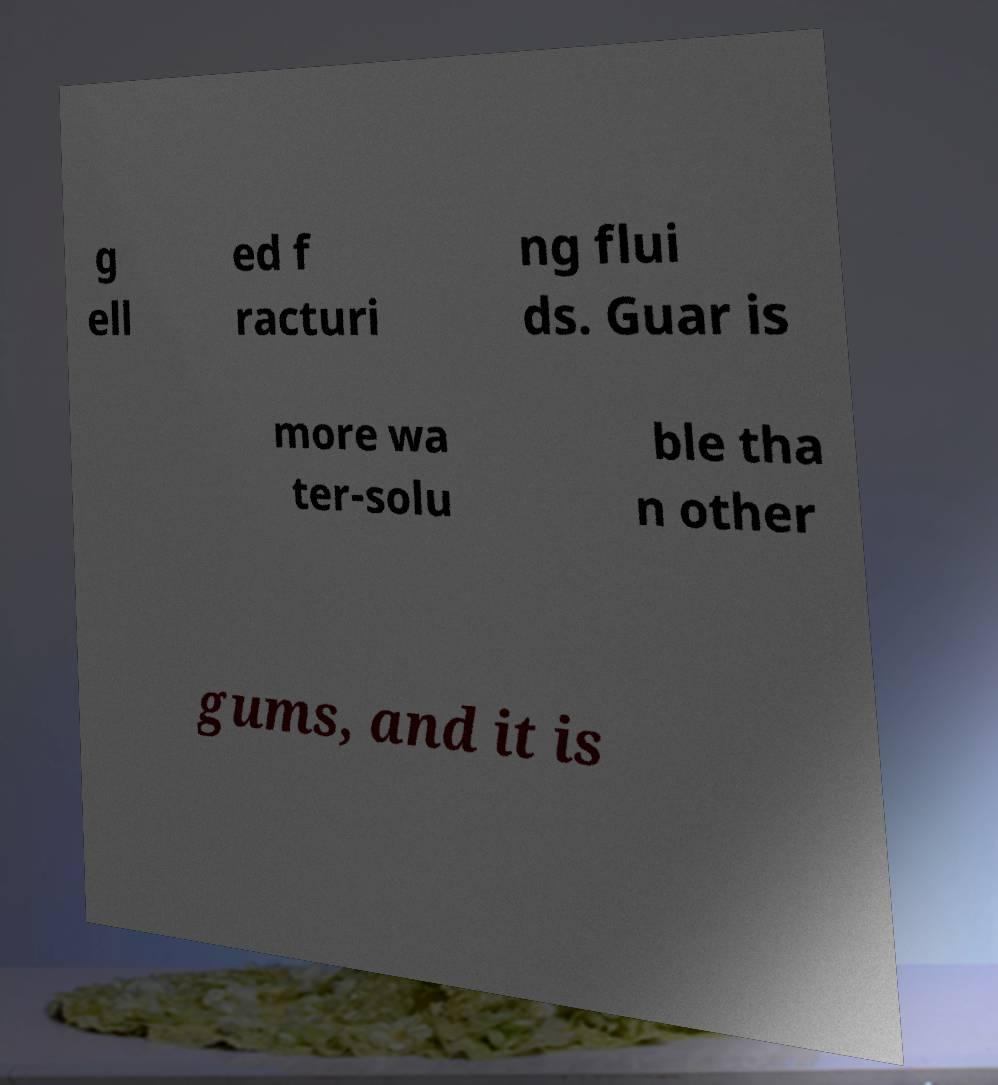Please identify and transcribe the text found in this image. g ell ed f racturi ng flui ds. Guar is more wa ter-solu ble tha n other gums, and it is 